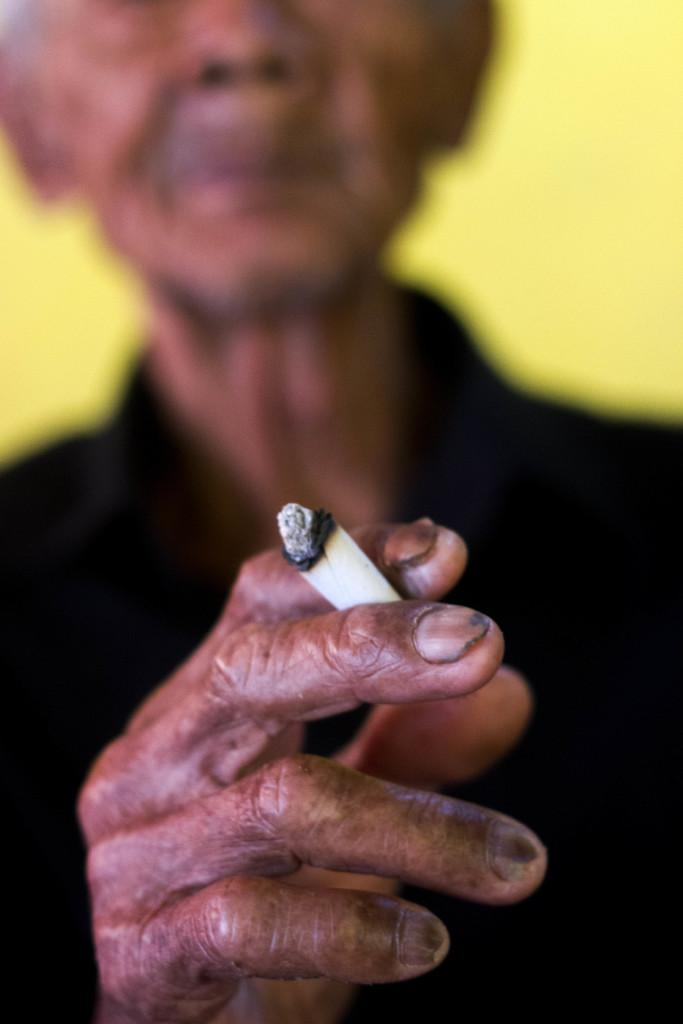What is present in the image? There is a person in the image. What is the person holding in his hand? The person is holding a cigarette in his hand. What type of brush can be seen in the person's hand in the image? There is no brush present in the person's hand in the image; they are holding a cigarette. 